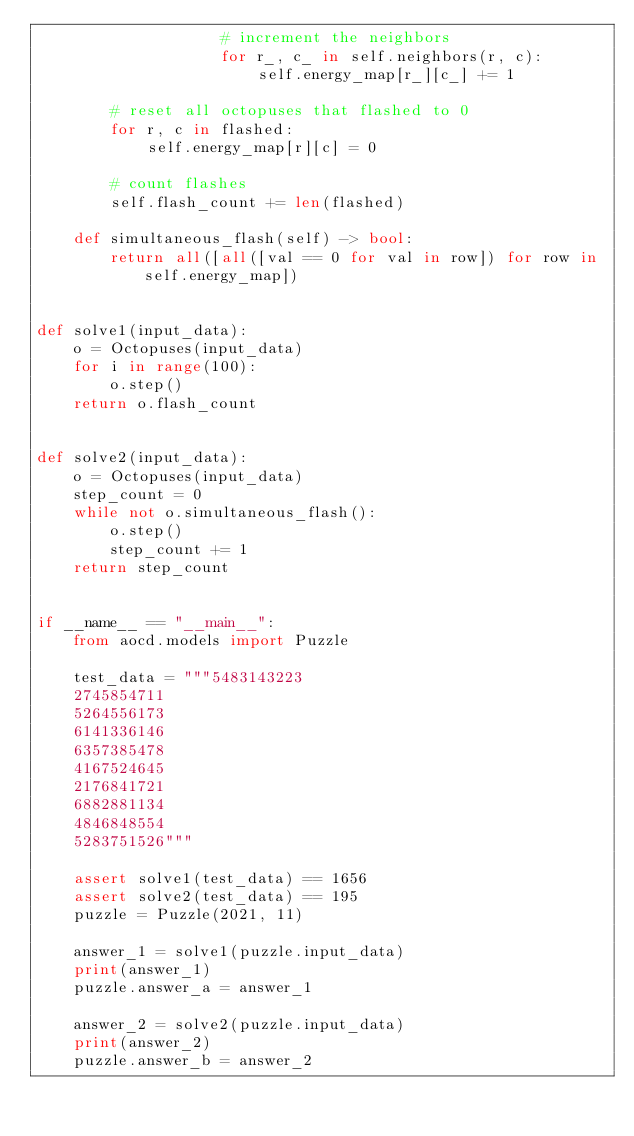<code> <loc_0><loc_0><loc_500><loc_500><_Python_>                    # increment the neighbors
                    for r_, c_ in self.neighbors(r, c):
                        self.energy_map[r_][c_] += 1

        # reset all octopuses that flashed to 0
        for r, c in flashed:
            self.energy_map[r][c] = 0

        # count flashes
        self.flash_count += len(flashed)

    def simultaneous_flash(self) -> bool:
        return all([all([val == 0 for val in row]) for row in self.energy_map])


def solve1(input_data):
    o = Octopuses(input_data)
    for i in range(100):
        o.step()
    return o.flash_count


def solve2(input_data):
    o = Octopuses(input_data)
    step_count = 0
    while not o.simultaneous_flash():
        o.step()
        step_count += 1
    return step_count


if __name__ == "__main__":
    from aocd.models import Puzzle

    test_data = """5483143223
    2745854711
    5264556173
    6141336146
    6357385478
    4167524645
    2176841721
    6882881134
    4846848554
    5283751526"""

    assert solve1(test_data) == 1656
    assert solve2(test_data) == 195
    puzzle = Puzzle(2021, 11)

    answer_1 = solve1(puzzle.input_data)
    print(answer_1)
    puzzle.answer_a = answer_1

    answer_2 = solve2(puzzle.input_data)
    print(answer_2)
    puzzle.answer_b = answer_2
</code> 